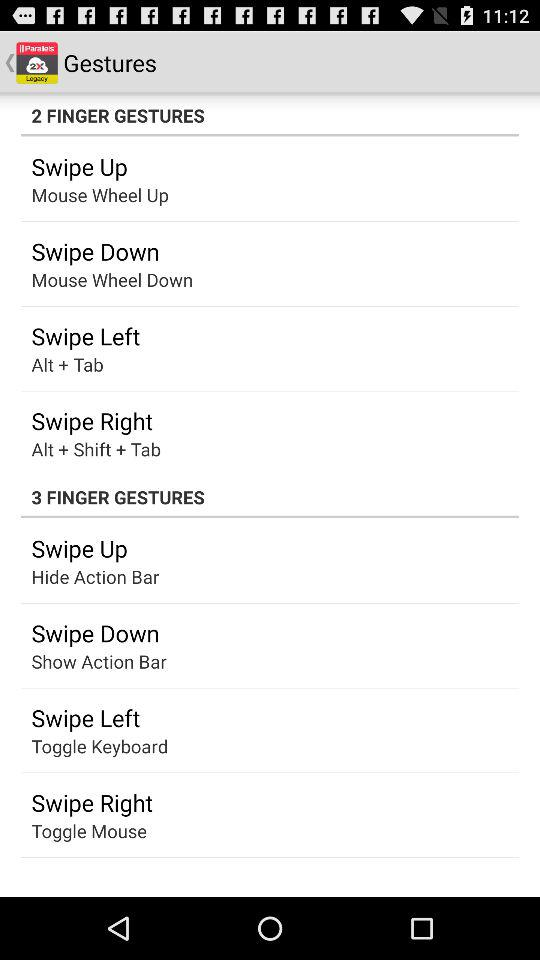What are the "2 FINGER GESTURES"? The "2 FINGER GESTURES" are "Swipe Up", "Swipe Down", "Swipe Left" and "Swipe Right". 